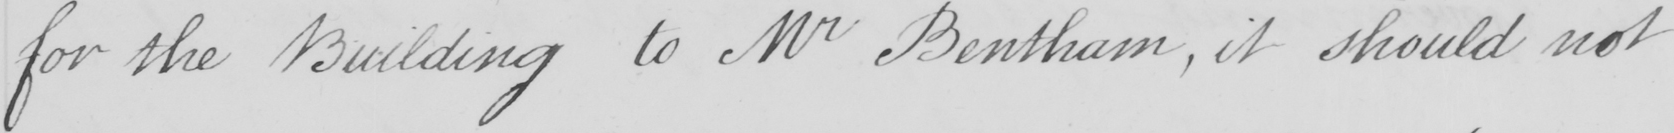Can you read and transcribe this handwriting? for the Building to Mr Bentham , it should not 